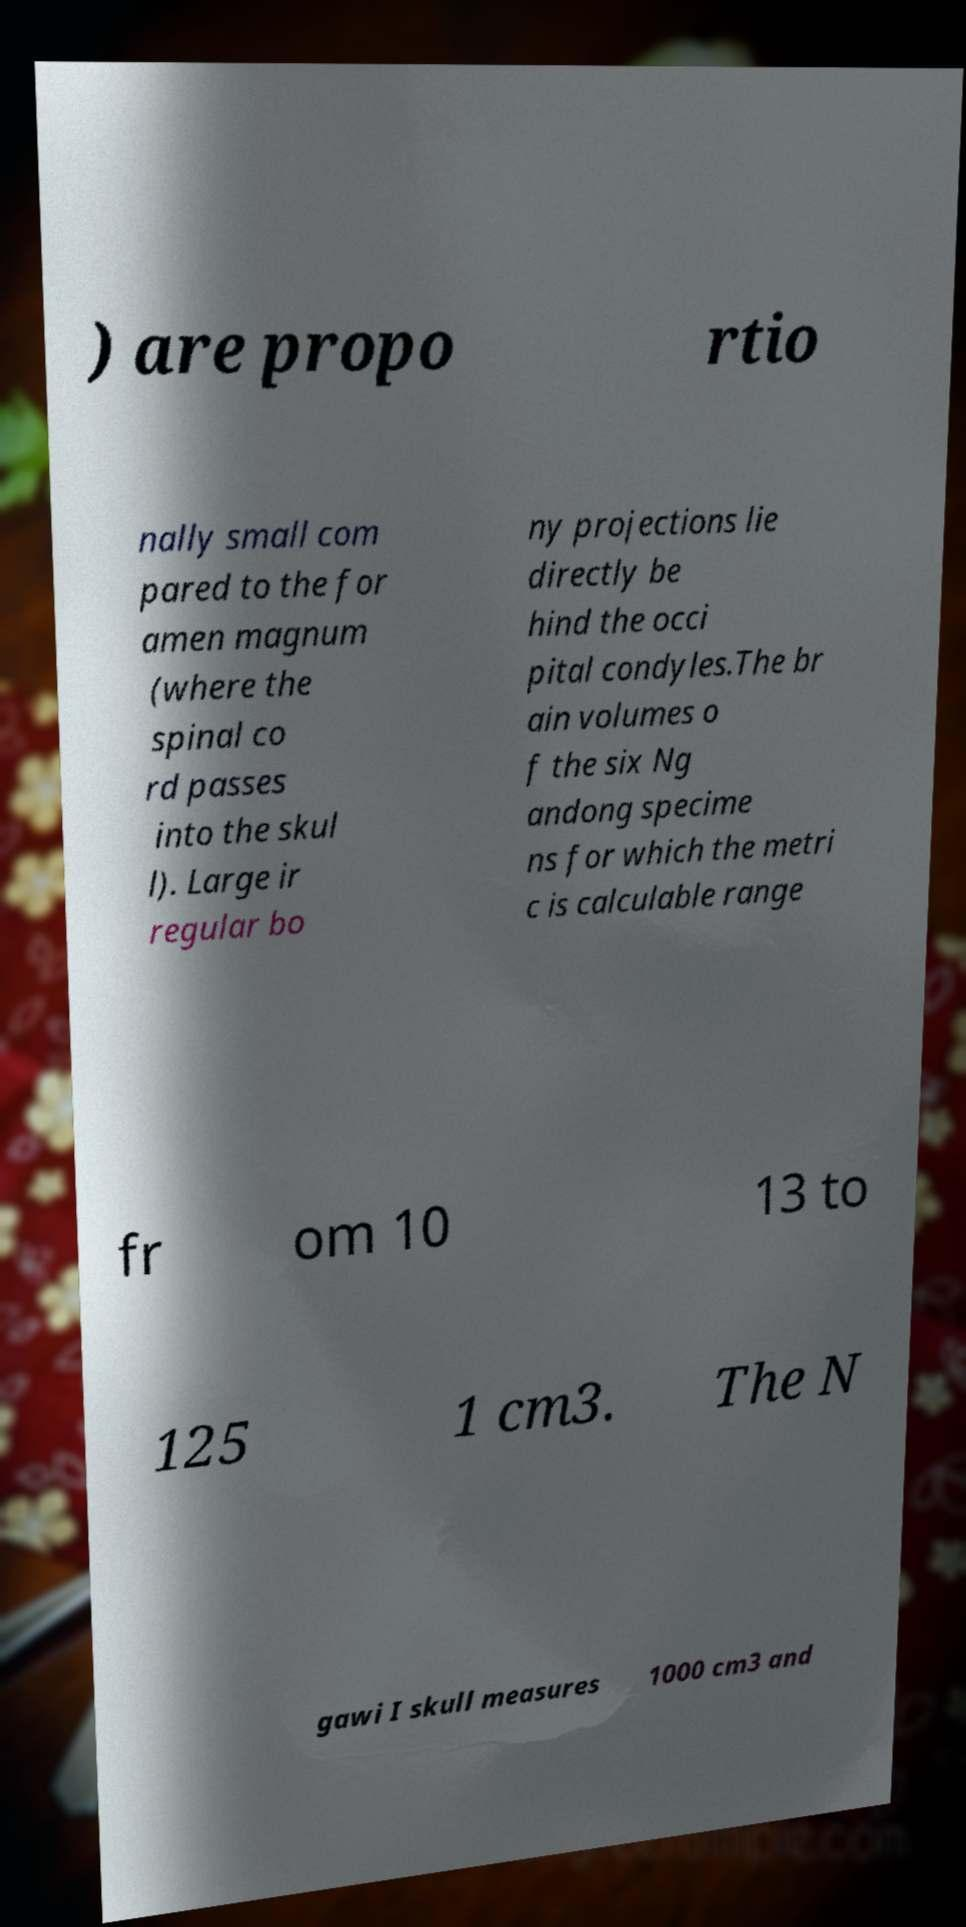Could you assist in decoding the text presented in this image and type it out clearly? ) are propo rtio nally small com pared to the for amen magnum (where the spinal co rd passes into the skul l). Large ir regular bo ny projections lie directly be hind the occi pital condyles.The br ain volumes o f the six Ng andong specime ns for which the metri c is calculable range fr om 10 13 to 125 1 cm3. The N gawi I skull measures 1000 cm3 and 